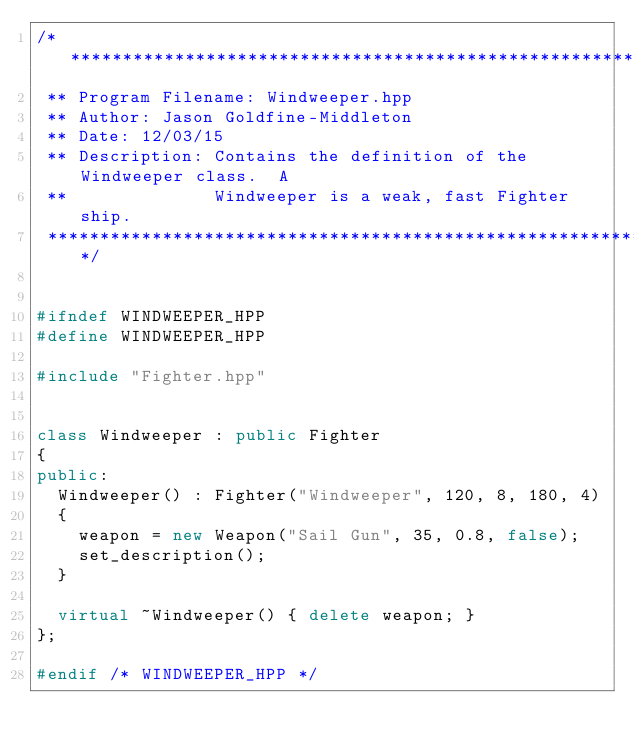<code> <loc_0><loc_0><loc_500><loc_500><_C++_>/*********************************************************************
 ** Program Filename: Windweeper.hpp
 ** Author: Jason Goldfine-Middleton
 ** Date: 12/03/15
 ** Description: Contains the definition of the Windweeper class.  A
 **              Windweeper is a weak, fast Fighter ship.
 *********************************************************************/


#ifndef WINDWEEPER_HPP
#define WINDWEEPER_HPP

#include "Fighter.hpp"


class Windweeper : public Fighter
{
public:
  Windweeper() : Fighter("Windweeper", 120, 8, 180, 4)
  {
    weapon = new Weapon("Sail Gun", 35, 0.8, false);
    set_description();
  }
  
  virtual ~Windweeper() { delete weapon; }
};

#endif /* WINDWEEPER_HPP */
</code> 